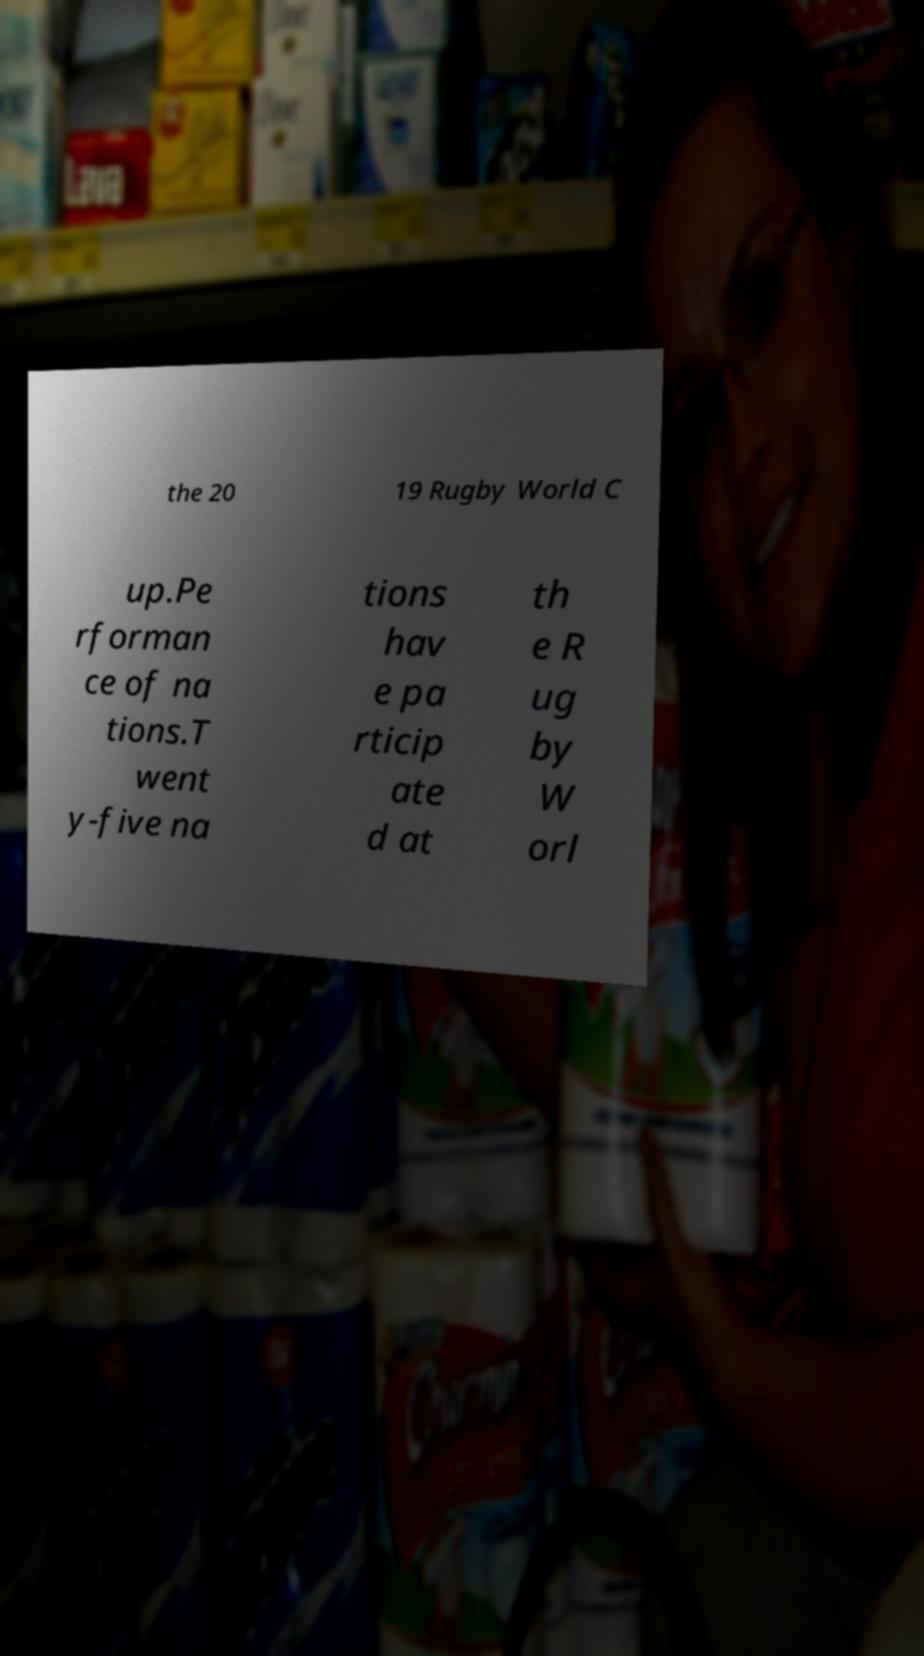I need the written content from this picture converted into text. Can you do that? the 20 19 Rugby World C up.Pe rforman ce of na tions.T went y-five na tions hav e pa rticip ate d at th e R ug by W orl 